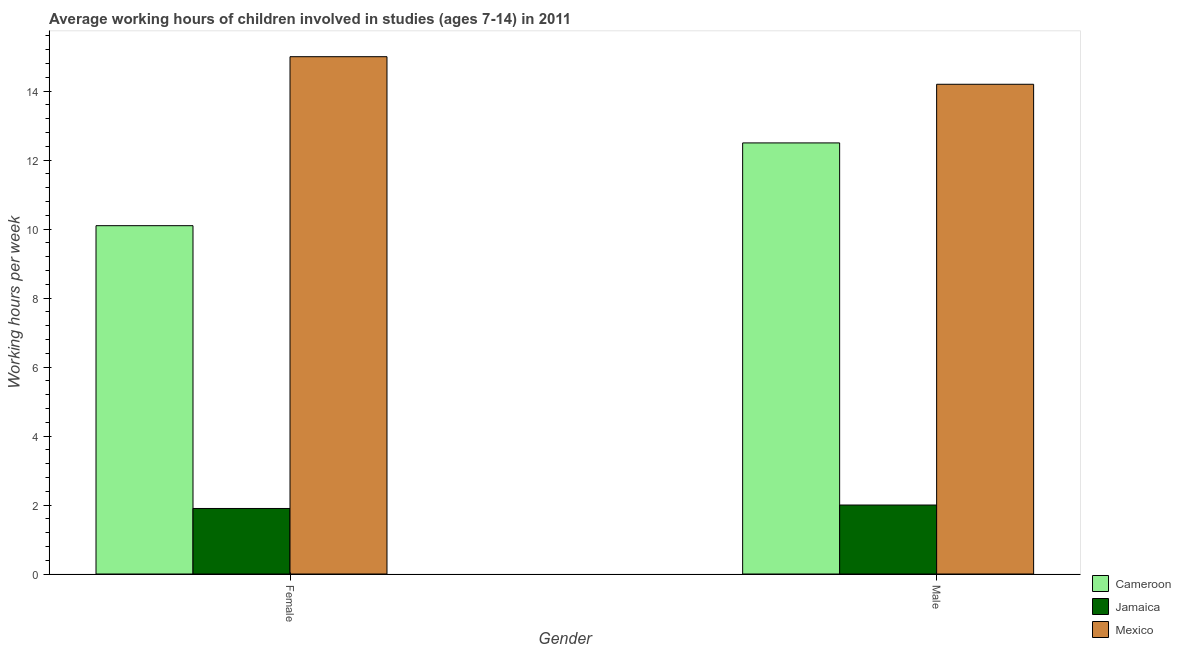How many groups of bars are there?
Make the answer very short. 2. Are the number of bars on each tick of the X-axis equal?
Provide a succinct answer. Yes. How many bars are there on the 2nd tick from the left?
Offer a very short reply. 3. How many bars are there on the 1st tick from the right?
Your answer should be compact. 3. What is the average working hour of male children in Mexico?
Your answer should be compact. 14.2. Across all countries, what is the minimum average working hour of female children?
Make the answer very short. 1.9. In which country was the average working hour of male children minimum?
Make the answer very short. Jamaica. What is the total average working hour of male children in the graph?
Make the answer very short. 28.7. What is the difference between the average working hour of male children in Cameroon and that in Jamaica?
Provide a short and direct response. 10.5. What is the difference between the average working hour of female children in Mexico and the average working hour of male children in Jamaica?
Your response must be concise. 13. What is the average average working hour of male children per country?
Provide a succinct answer. 9.57. What is the difference between the average working hour of female children and average working hour of male children in Jamaica?
Ensure brevity in your answer.  -0.1. In how many countries, is the average working hour of male children greater than 6 hours?
Your answer should be very brief. 2. What is the ratio of the average working hour of female children in Mexico to that in Jamaica?
Your answer should be very brief. 7.89. Is the average working hour of male children in Mexico less than that in Jamaica?
Your answer should be very brief. No. What does the 3rd bar from the left in Male represents?
Keep it short and to the point. Mexico. What does the 2nd bar from the right in Male represents?
Offer a terse response. Jamaica. How many bars are there?
Make the answer very short. 6. Are all the bars in the graph horizontal?
Ensure brevity in your answer.  No. What is the difference between two consecutive major ticks on the Y-axis?
Your answer should be very brief. 2. How many legend labels are there?
Offer a terse response. 3. What is the title of the graph?
Your answer should be very brief. Average working hours of children involved in studies (ages 7-14) in 2011. Does "Lower middle income" appear as one of the legend labels in the graph?
Your answer should be compact. No. What is the label or title of the X-axis?
Provide a short and direct response. Gender. What is the label or title of the Y-axis?
Provide a short and direct response. Working hours per week. What is the Working hours per week of Cameroon in Female?
Keep it short and to the point. 10.1. What is the Working hours per week of Cameroon in Male?
Your response must be concise. 12.5. Across all Gender, what is the maximum Working hours per week in Jamaica?
Offer a terse response. 2. Across all Gender, what is the minimum Working hours per week of Jamaica?
Your answer should be compact. 1.9. Across all Gender, what is the minimum Working hours per week of Mexico?
Ensure brevity in your answer.  14.2. What is the total Working hours per week of Cameroon in the graph?
Keep it short and to the point. 22.6. What is the total Working hours per week in Jamaica in the graph?
Provide a succinct answer. 3.9. What is the total Working hours per week of Mexico in the graph?
Keep it short and to the point. 29.2. What is the difference between the Working hours per week in Cameroon in Female and the Working hours per week in Mexico in Male?
Provide a short and direct response. -4.1. What is the difference between the Working hours per week in Jamaica in Female and the Working hours per week in Mexico in Male?
Make the answer very short. -12.3. What is the average Working hours per week in Jamaica per Gender?
Make the answer very short. 1.95. What is the average Working hours per week in Mexico per Gender?
Your answer should be compact. 14.6. What is the difference between the Working hours per week of Cameroon and Working hours per week of Jamaica in Male?
Provide a succinct answer. 10.5. What is the difference between the Working hours per week in Cameroon and Working hours per week in Mexico in Male?
Provide a succinct answer. -1.7. What is the difference between the Working hours per week in Jamaica and Working hours per week in Mexico in Male?
Make the answer very short. -12.2. What is the ratio of the Working hours per week of Cameroon in Female to that in Male?
Your answer should be very brief. 0.81. What is the ratio of the Working hours per week in Mexico in Female to that in Male?
Keep it short and to the point. 1.06. What is the difference between the highest and the second highest Working hours per week in Jamaica?
Your answer should be very brief. 0.1. What is the difference between the highest and the second highest Working hours per week in Mexico?
Your response must be concise. 0.8. What is the difference between the highest and the lowest Working hours per week of Cameroon?
Provide a short and direct response. 2.4. 